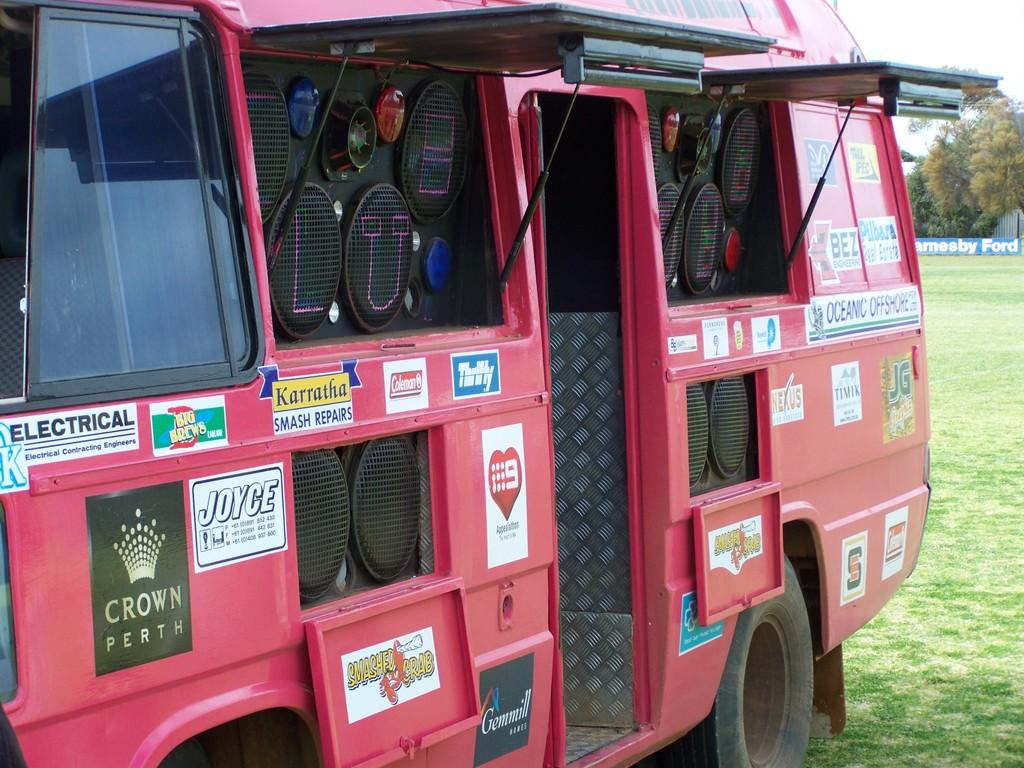What is on the ground in the image? There is a vehicle on the ground in the image. What can be seen in the background of the image? There is an advertisement board, trees, grass, and an unspecified object in the background of the image. What type of straw is being used to drink from the vehicle in the image? There is no straw or drinking activity present in the image; it features a vehicle on the ground and various background elements. 